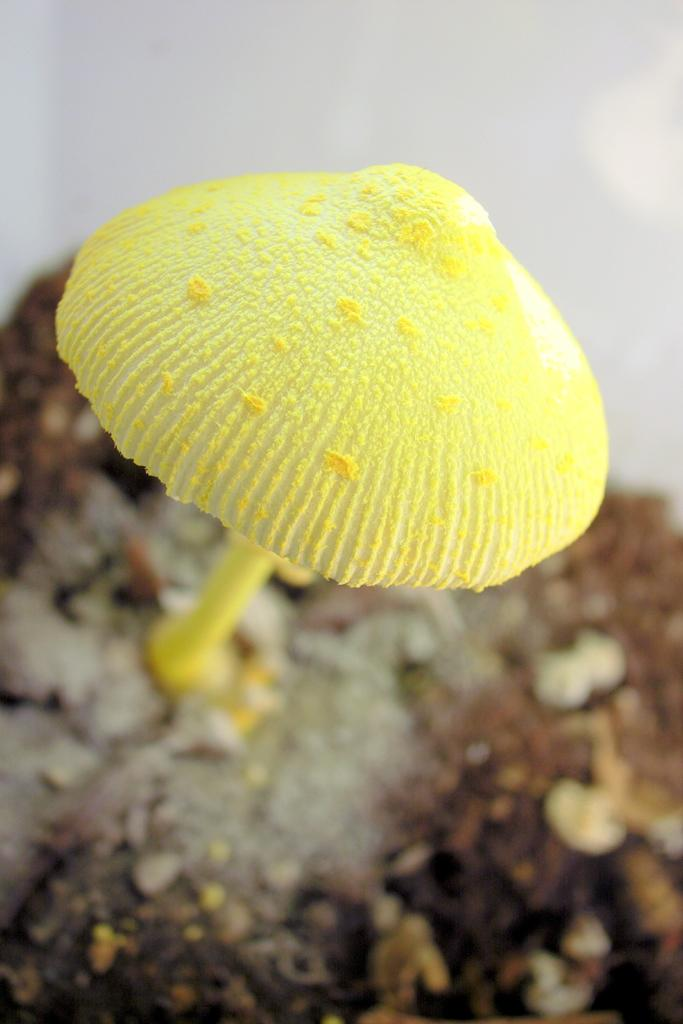What is the main subject of the image? There is a mushroom in the image. Can you describe the color of the mushroom? The mushroom is yellow in color. What can be observed about the background of the image? The background of the image is blurred. What type of fiction is the mushroom reading in the image? There is no indication in the image that the mushroom is reading any fiction, as mushrooms do not have the ability to read. 